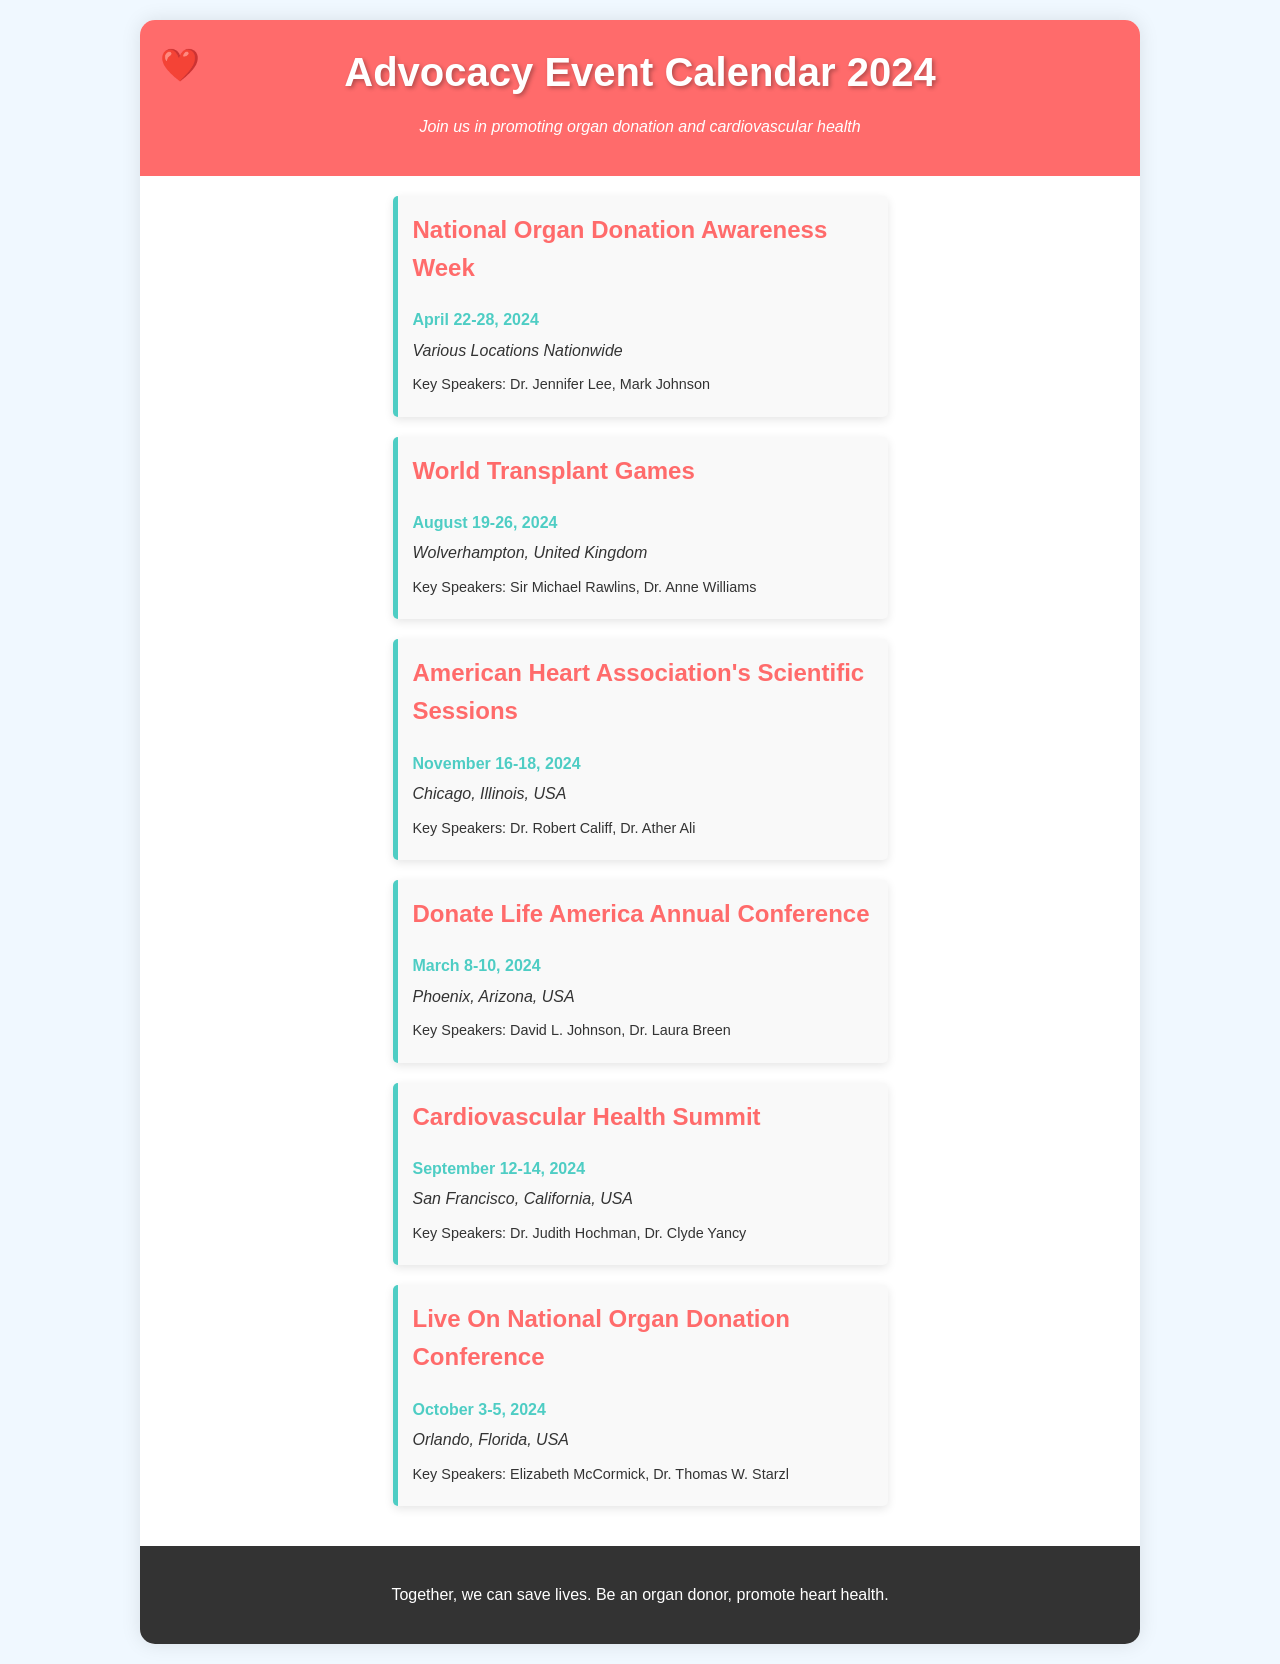what is the date for National Organ Donation Awareness Week? The date for National Organ Donation Awareness Week is clearly stated in the document.
Answer: April 22-28, 2024 where is the World Transplant Games taking place? The location for the World Transplant Games is mentioned in the event details in the document.
Answer: Wolverhampton, United Kingdom who are the key speakers for the American Heart Association's Scientific Sessions? The document lists the key speakers for this specific event.
Answer: Dr. Robert Califf, Dr. Ather Ali how many days does the Donate Life America Annual Conference last? The duration of the conference is indicated by the start and end dates mentioned in the document.
Answer: 3 days which event is scheduled in Phoenix, Arizona? The document highlights specific events along with their locations, making this information straightforward to identify.
Answer: Donate Life America Annual Conference what event occurs closest to September 2024? The reasoning involves looking for events scheduled in relation to September within the document.
Answer: Cardiovascular Health Summit which state hosts the Live On National Organ Donation Conference? The document specifies the location of each event, making it easy to find the state for this event.
Answer: Florida when is the Cardiovascular Health Summit? This question asks for the specific dates listed in the document for this event.
Answer: September 12-14, 2024 who is a speaker at the National Organ Donation Awareness Week? The document indicates the key speakers for each event, including this specific one.
Answer: Dr. Jennifer Lee 